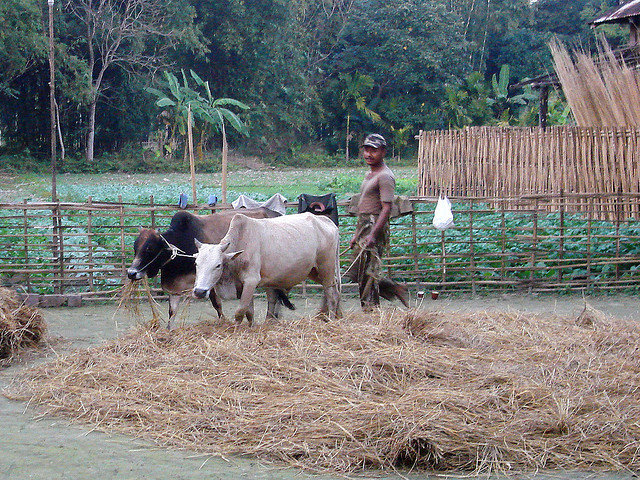What diet are the cows here on?
A. milk
B. fasting
C. vegan
D. carnivorous
Answer with the option's letter from the given choices directly. Option C, vegan, is the correct answer. Cows are herbivores, meaning their diet consists mainly of grass and other plant-based materials. The cows in this image are likely feeding on the straw laid out for them, which is typical fodder for cattle. 